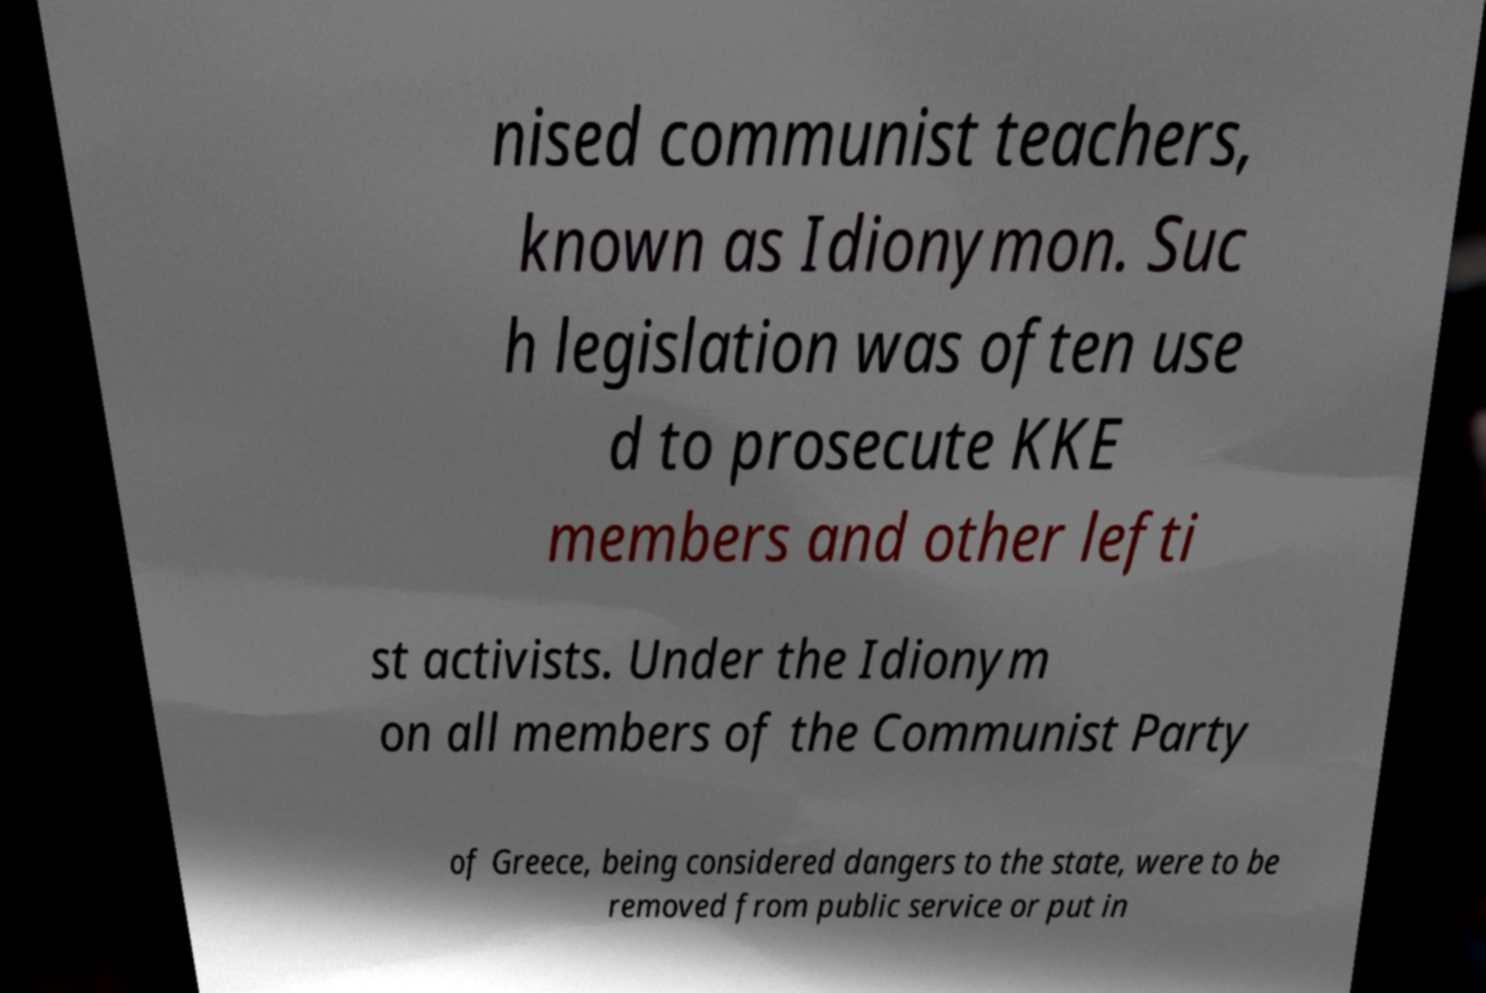I need the written content from this picture converted into text. Can you do that? nised communist teachers, known as Idionymon. Suc h legislation was often use d to prosecute KKE members and other lefti st activists. Under the Idionym on all members of the Communist Party of Greece, being considered dangers to the state, were to be removed from public service or put in 